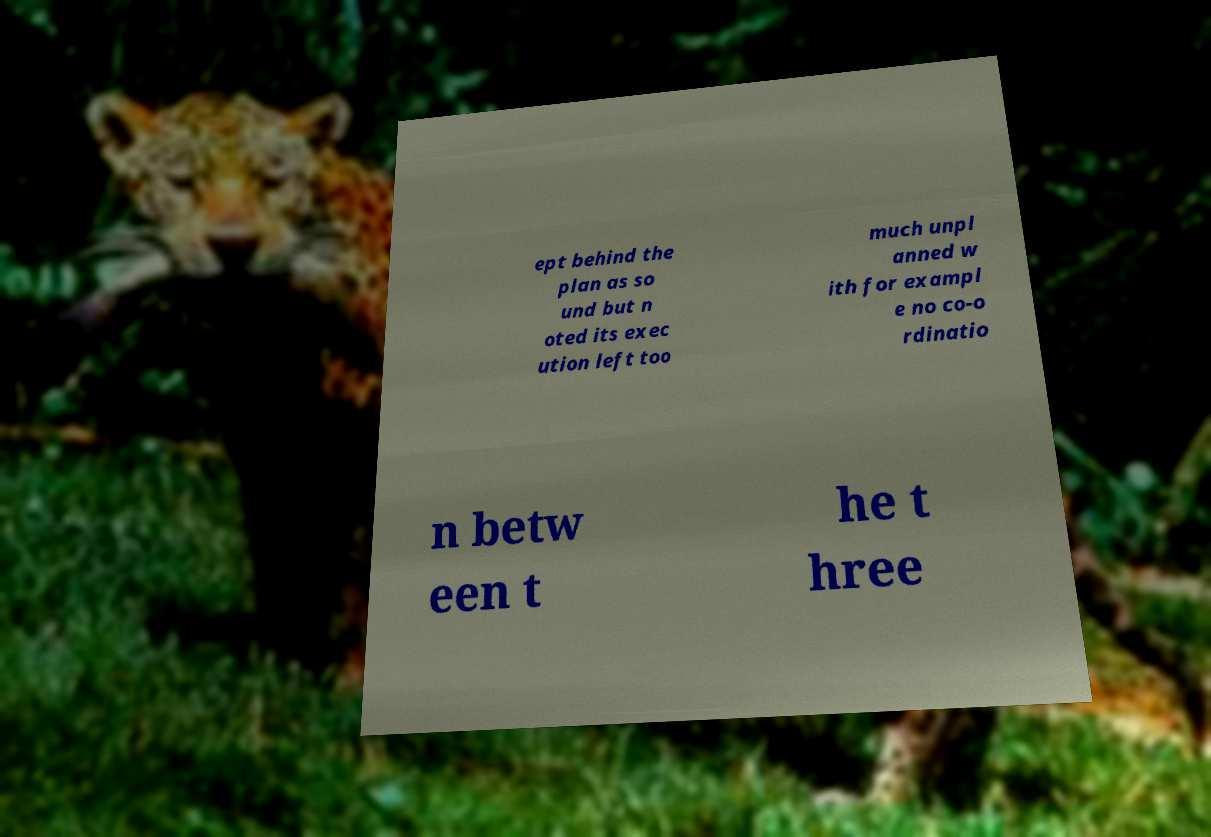There's text embedded in this image that I need extracted. Can you transcribe it verbatim? ept behind the plan as so und but n oted its exec ution left too much unpl anned w ith for exampl e no co-o rdinatio n betw een t he t hree 